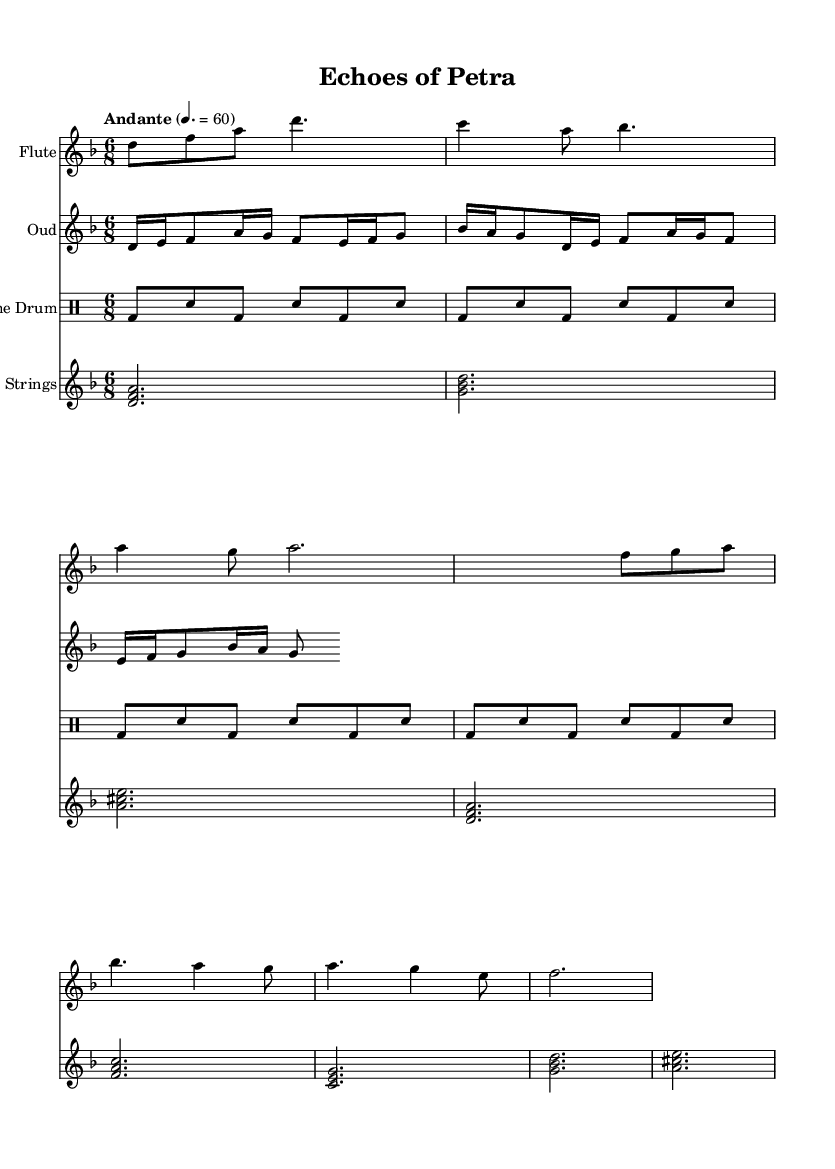What is the key signature of this music? The key signature is D minor, which has one flat (B flat). This can be found at the beginning of the staff where the key signature is indicated.
Answer: D minor What is the time signature of this music? The time signature is 6/8, shown at the beginning of the sheet music. This means there are six eighth notes in each measure.
Answer: 6/8 What is the tempo marking for the piece? The tempo marking is "Andante," indicated above the staff. In this piece, it provides a slow, walking pace, generally around 60 beats per minute.
Answer: Andante How many measures are in the flute part? The flute part consists of a total of 8 measures, as counted from the beginning to the end of the specified passages.
Answer: 8 What is the first instrument notated in the score? The first instrument notated in the score is the Flute, as indicated by the label at the beginning of the staff.
Answer: Flute Which instruments are indicated to play simultaneous parts? The instruments playing simultaneous parts are the Oud, Flute, Frame Drum, and Strings, as each of their staves is displayed vertically aligned together.
Answer: Oud, Flute, Frame Drum, Strings What rhythmic pattern is repeated in the frame drum part? The frame drum part contains a rhythmic pattern of bass drum and snare, repeating a sequence of two beats each (bass drum followed by snare). This repeating pattern can clearly be seen across four measures.
Answer: Bass drum, snare 